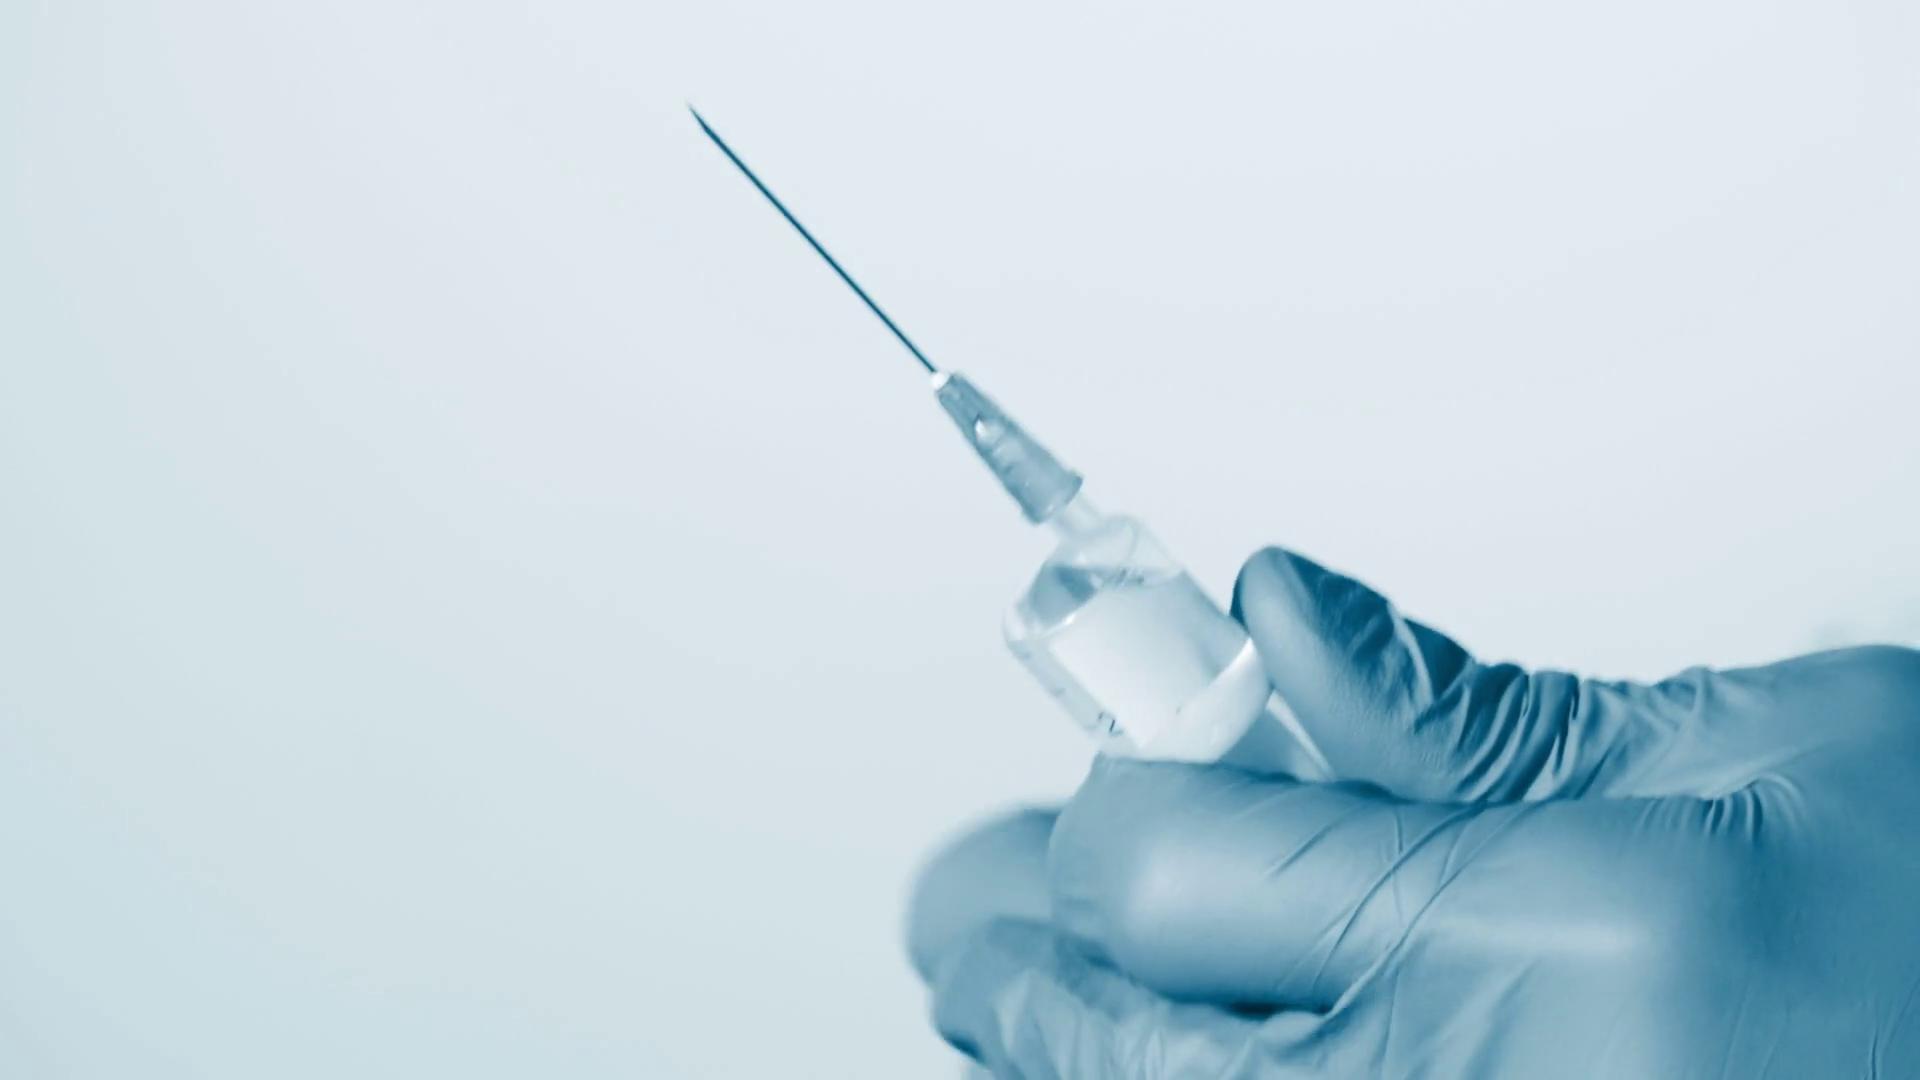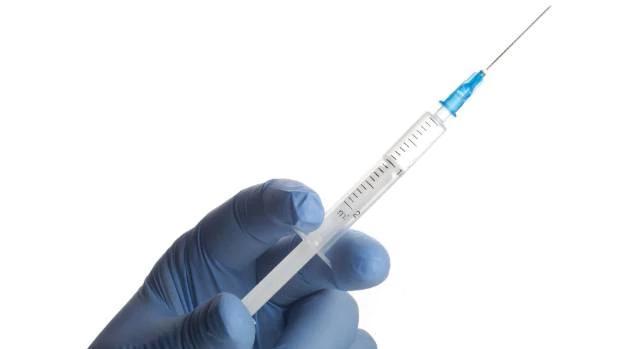The first image is the image on the left, the second image is the image on the right. Assess this claim about the two images: "There are two needles with at least two blue gloves.". Correct or not? Answer yes or no. Yes. 